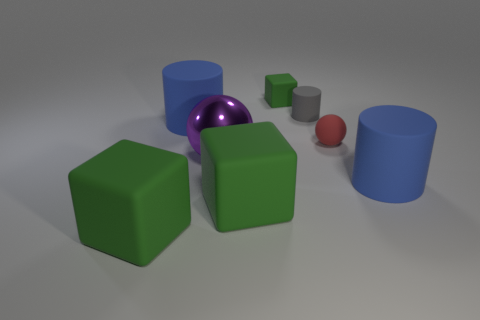Are there more rubber blocks than small gray matte cylinders?
Offer a terse response. Yes. Is there a blue object of the same shape as the red thing?
Offer a very short reply. No. There is a large blue rubber object that is right of the tiny green matte cube; what is its shape?
Offer a very short reply. Cylinder. There is a cylinder behind the big blue rubber thing that is to the left of the tiny block; what number of purple things are on the right side of it?
Keep it short and to the point. 0. There is a big rubber cylinder that is to the left of the big metal object; is its color the same as the small matte cylinder?
Offer a very short reply. No. How many other things are there of the same shape as the large shiny object?
Your response must be concise. 1. How many other objects are the same material as the purple object?
Provide a short and direct response. 0. What material is the big blue cylinder right of the blue matte object that is on the left side of the tiny object to the left of the small matte cylinder?
Give a very brief answer. Rubber. Is the gray cylinder made of the same material as the small sphere?
Provide a succinct answer. Yes. How many cylinders are either big green metal things or tiny rubber objects?
Your answer should be compact. 1. 